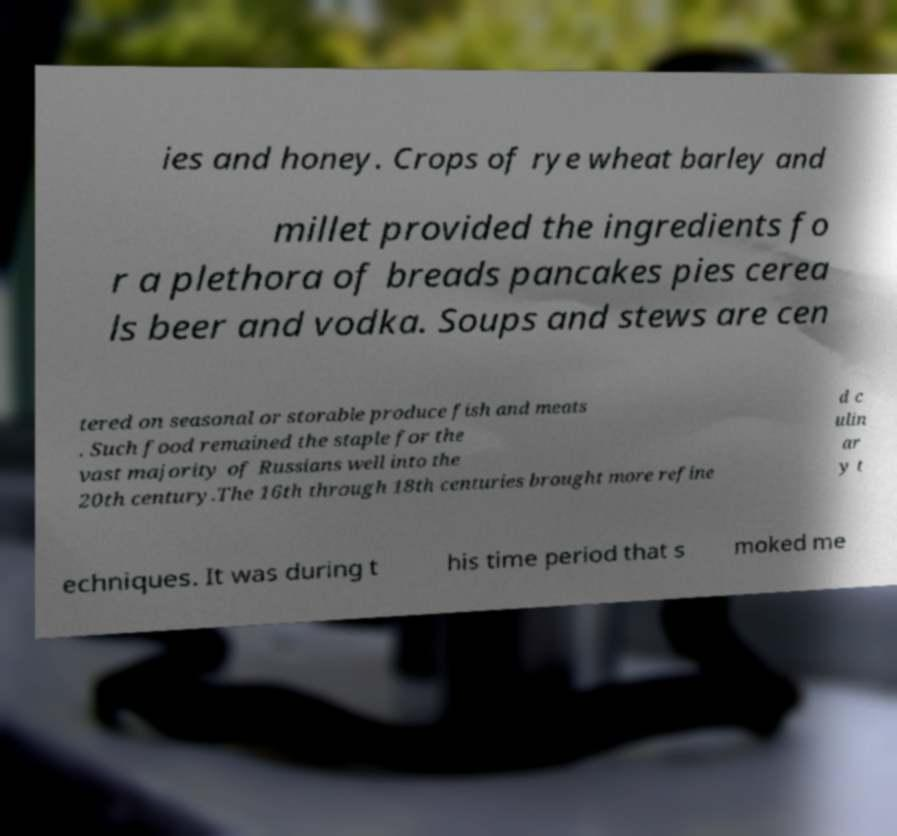For documentation purposes, I need the text within this image transcribed. Could you provide that? ies and honey. Crops of rye wheat barley and millet provided the ingredients fo r a plethora of breads pancakes pies cerea ls beer and vodka. Soups and stews are cen tered on seasonal or storable produce fish and meats . Such food remained the staple for the vast majority of Russians well into the 20th century.The 16th through 18th centuries brought more refine d c ulin ar y t echniques. It was during t his time period that s moked me 